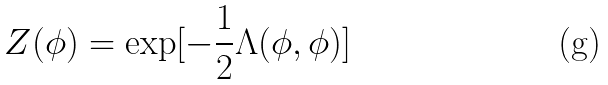<formula> <loc_0><loc_0><loc_500><loc_500>Z ( \phi ) = \exp [ - \frac { 1 } { 2 } \Lambda ( \phi , \phi ) ]</formula> 